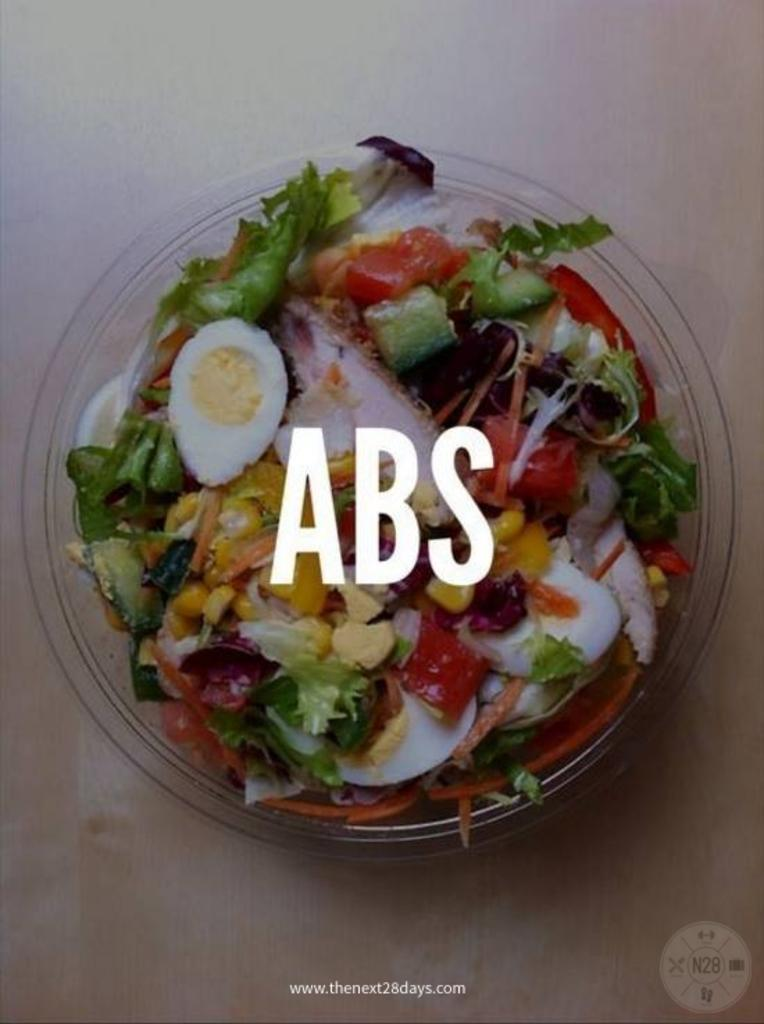What is in the bowl that is visible in the image? There is a bowl with a food item in the image. Can you describe anything else that is present in the image? Yes, there is edited text in the middle of the image. What type of fire can be seen in the image? There is no fire present in the image. What scientific experiment is being conducted in the image? There is no scientific experiment or any reference to science in the image. 